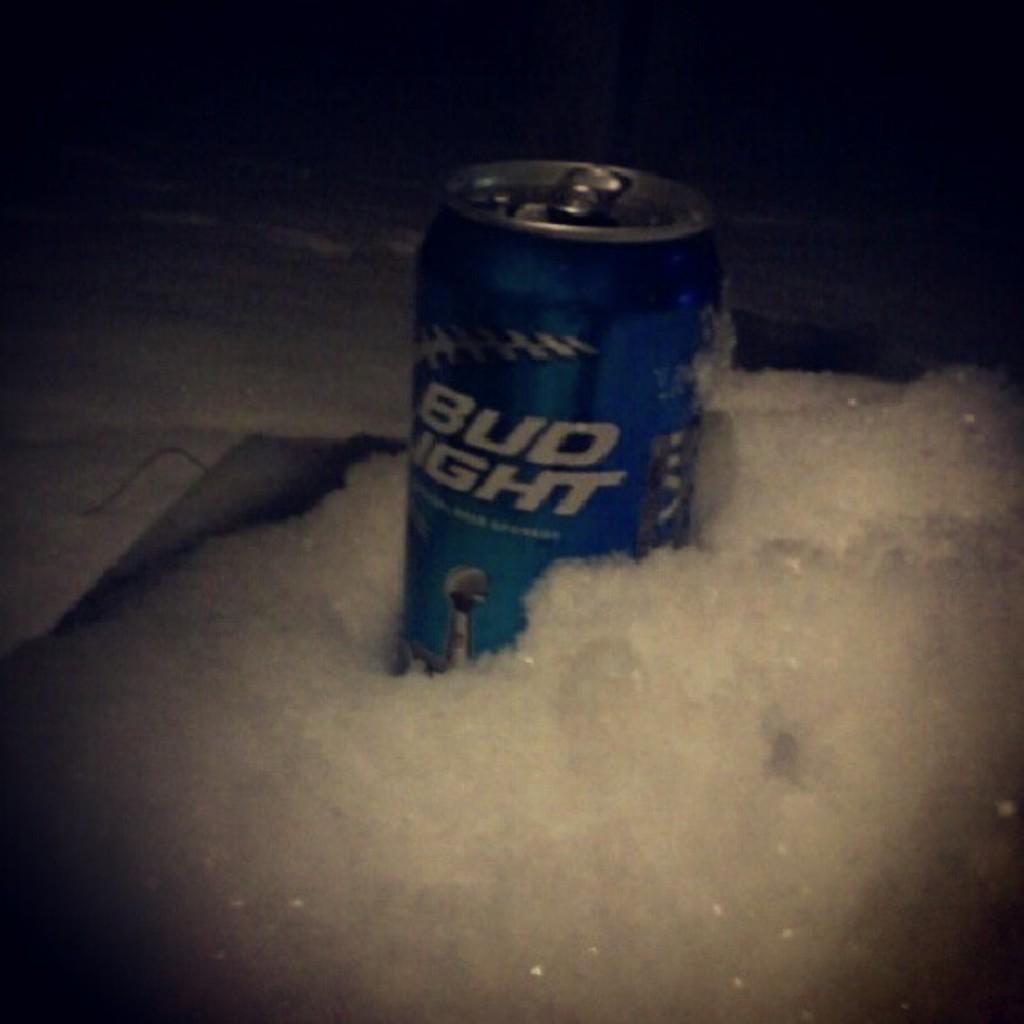<image>
Render a clear and concise summary of the photo. a Bud light can surrounded by some suds 